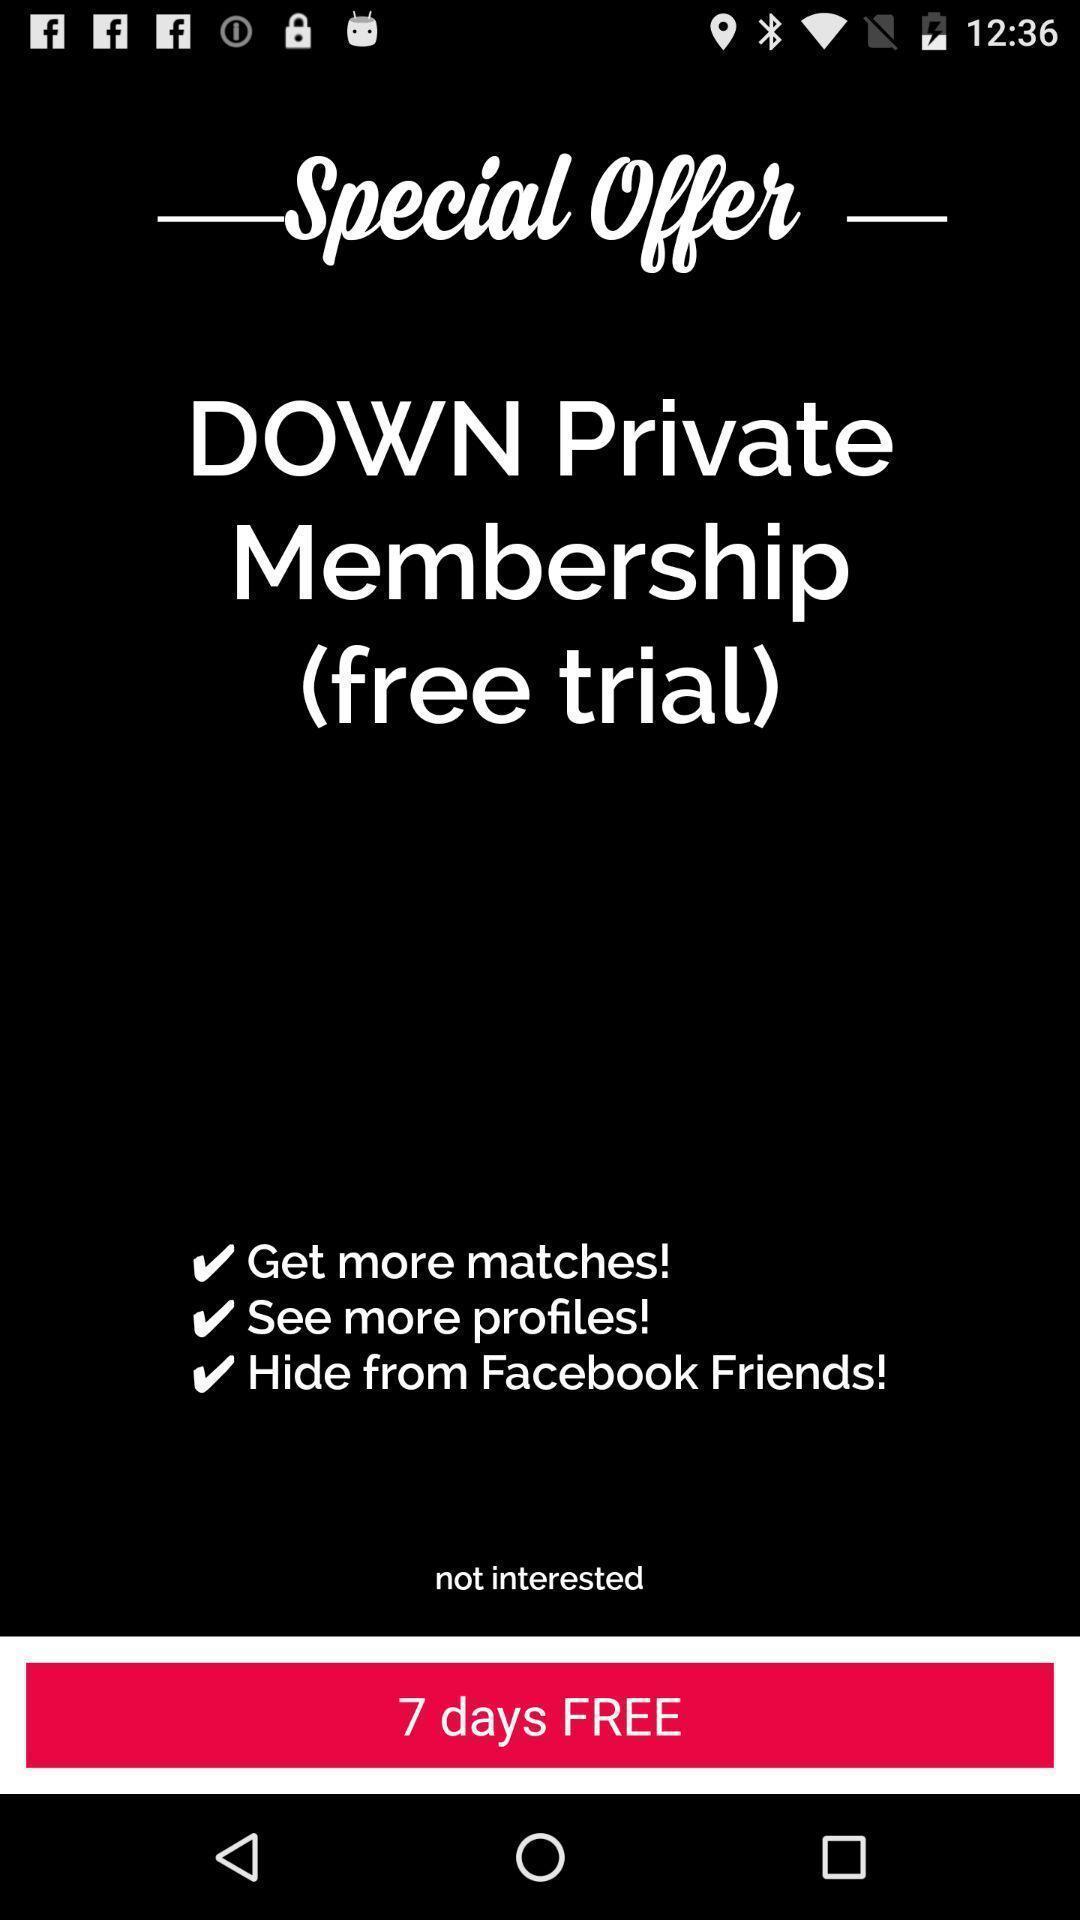Describe this image in words. Trial page. 